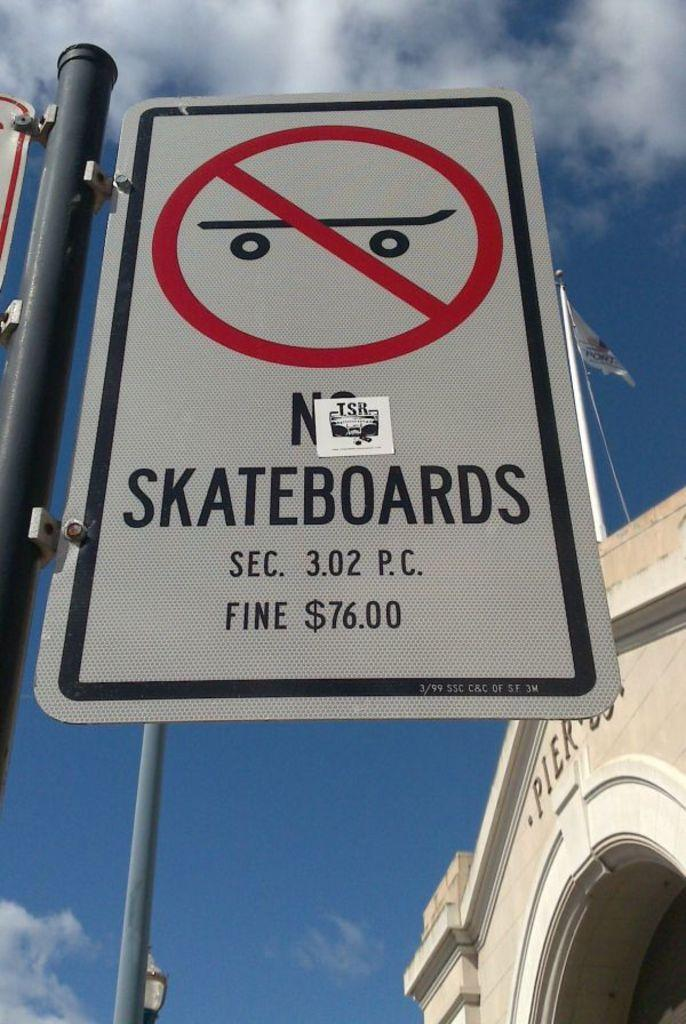<image>
Describe the image concisely. A sign that says No Skateboards on it. 